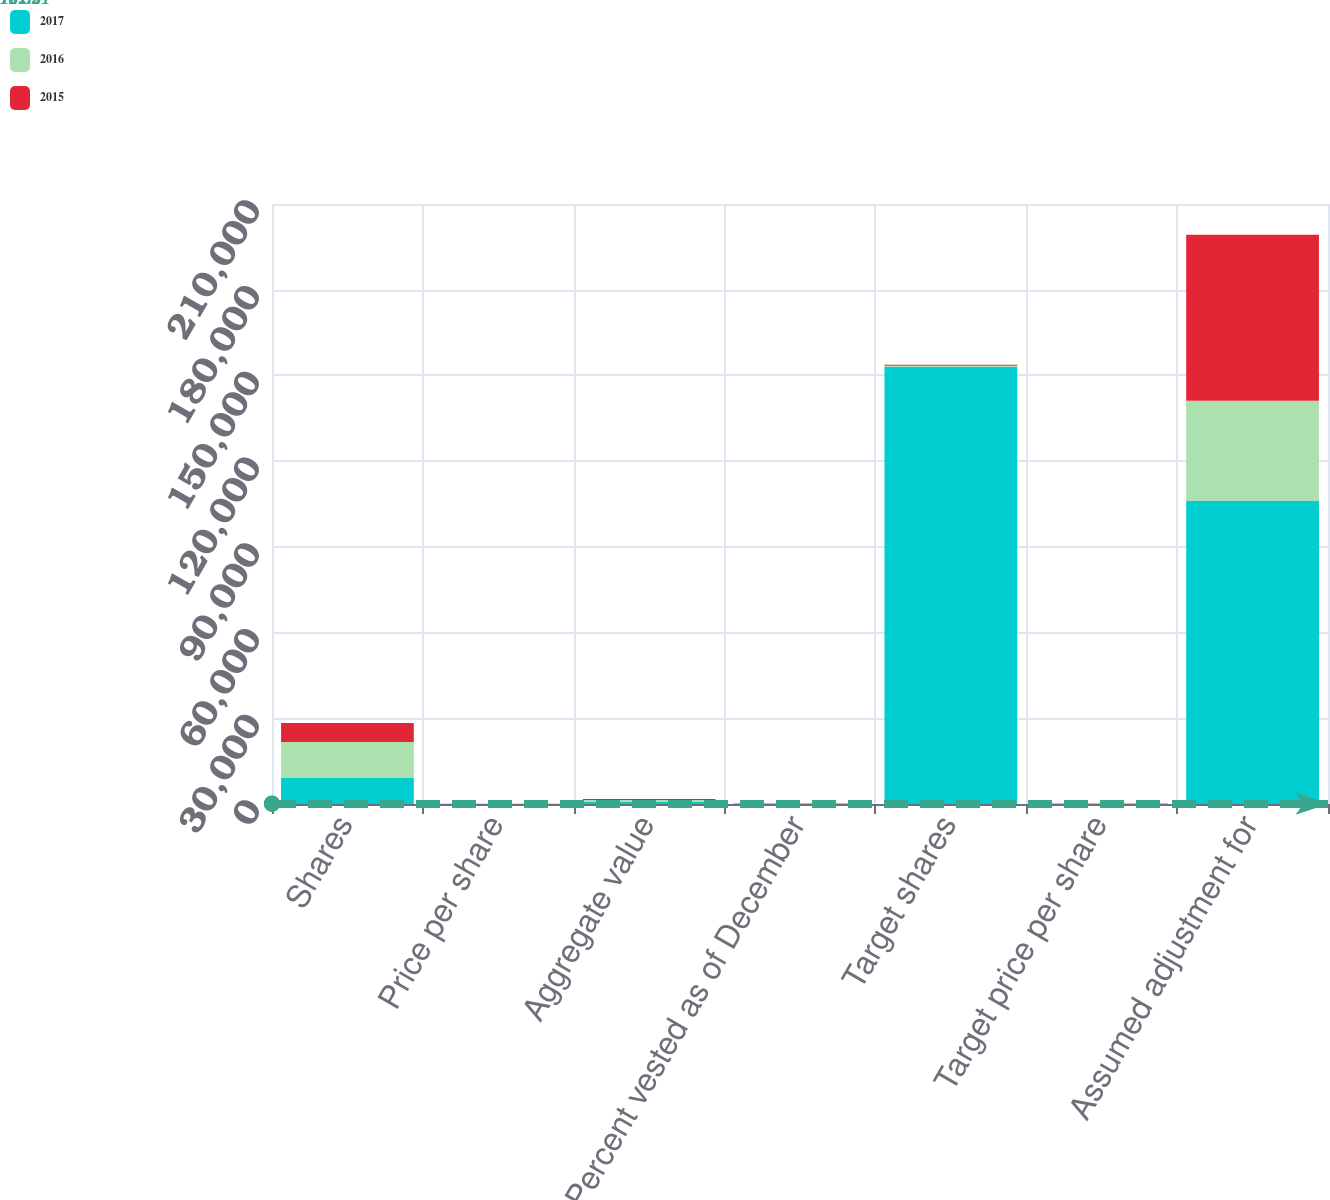<chart> <loc_0><loc_0><loc_500><loc_500><stacked_bar_chart><ecel><fcel>Shares<fcel>Price per share<fcel>Aggregate value<fcel>Percent vested as of December<fcel>Target shares<fcel>Target price per share<fcel>Assumed adjustment for<nl><fcel>2017<fcel>9135<fcel>73.92<fcel>675<fcel>100<fcel>153000<fcel>77.26<fcel>106084<nl><fcel>2016<fcel>12549<fcel>57.39<fcel>720<fcel>85<fcel>360<fcel>50.64<fcel>35073<nl><fcel>2015<fcel>6648<fcel>54.16<fcel>360<fcel>100<fcel>360<fcel>53.61<fcel>58056<nl></chart> 